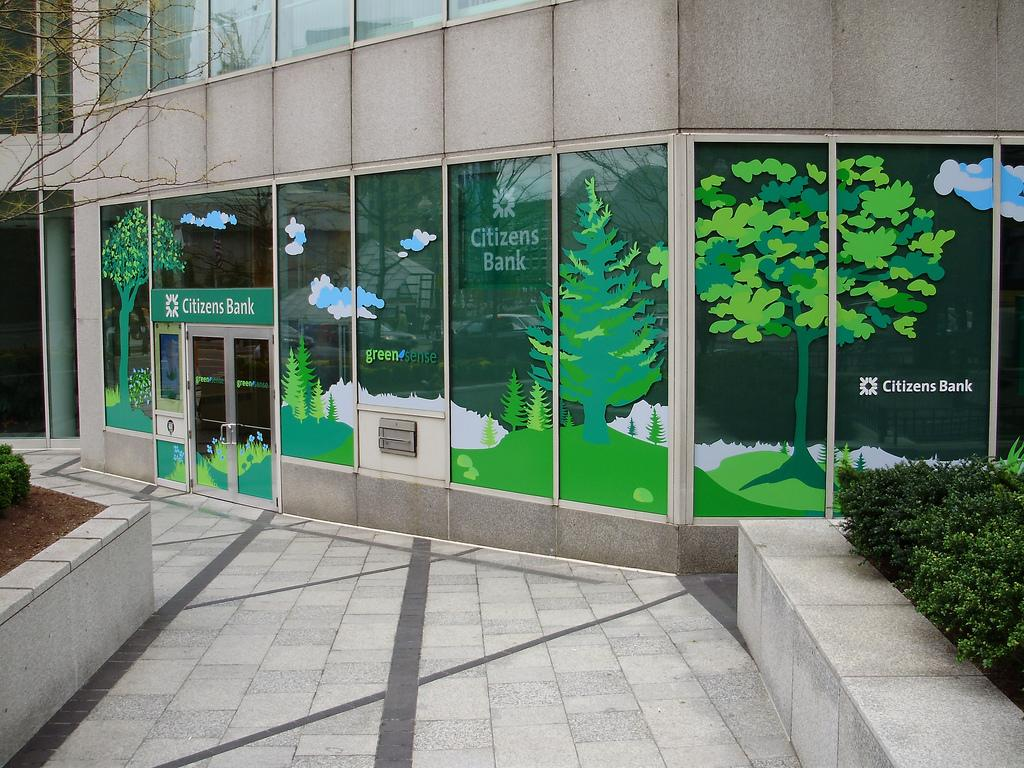What type of building is in the image? There is a bank in the image. What is located in front of the bank? There is a pavement in front of the bank. What type of vegetation is present on either side of the pavement? There are plants on either side of the pavement. How many babies are visible in the image? There are no babies present in the image. What type of self-improvement activity is taking place in the image? There is no self-improvement activity depicted in the image. 